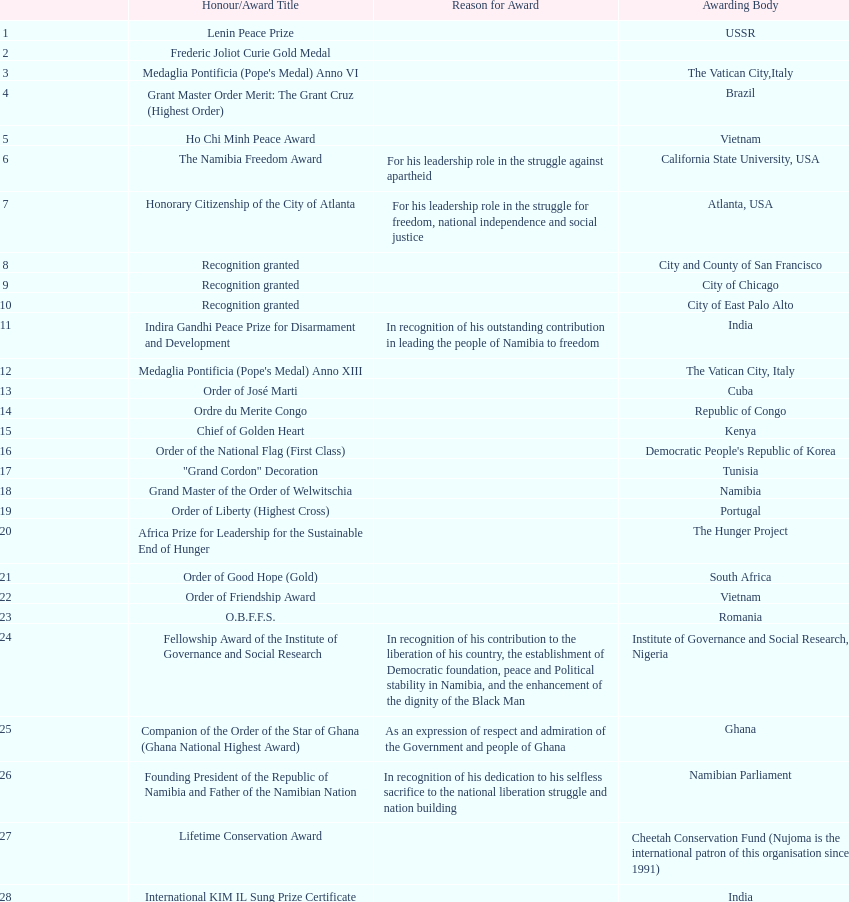What is the variation in the amount of awards achieved in 1988 compared to the amount of awards achieved in 1995? 4. 